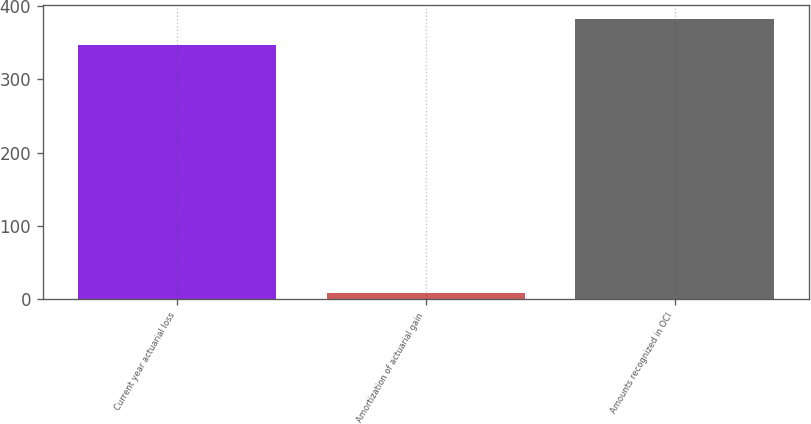<chart> <loc_0><loc_0><loc_500><loc_500><bar_chart><fcel>Current year actuarial loss<fcel>Amortization of actuarial gain<fcel>Amounts recognized in OCI<nl><fcel>347<fcel>9<fcel>381.9<nl></chart> 